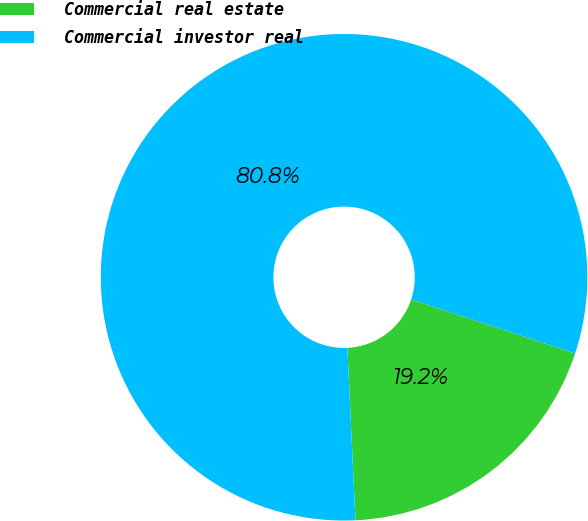<chart> <loc_0><loc_0><loc_500><loc_500><pie_chart><fcel>Commercial real estate<fcel>Commercial investor real<nl><fcel>19.18%<fcel>80.82%<nl></chart> 